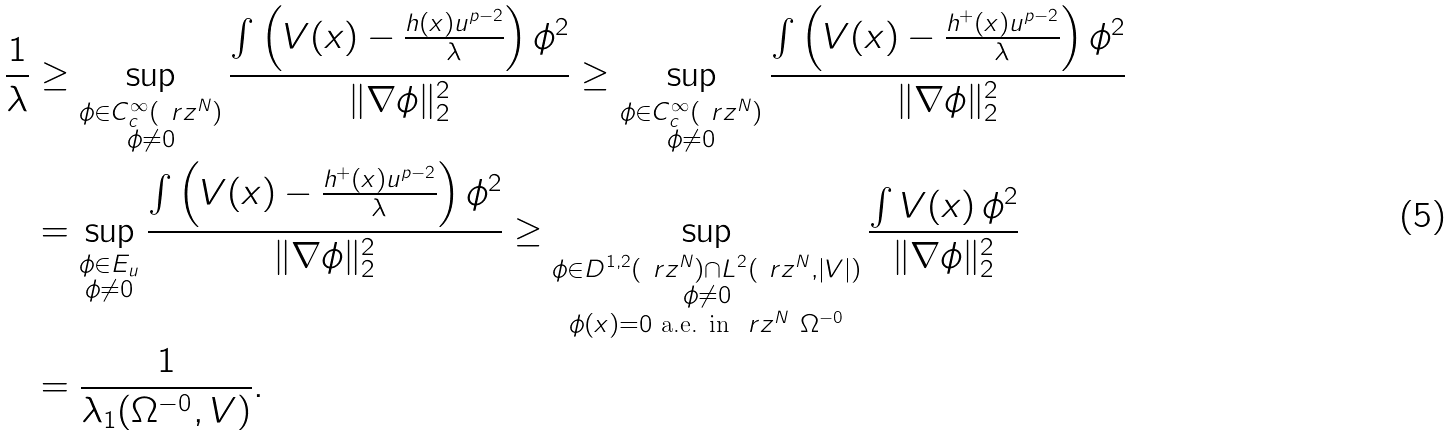Convert formula to latex. <formula><loc_0><loc_0><loc_500><loc_500>\frac { 1 } { \lambda } & \geq \sup _ { \substack { \phi \in C _ { c } ^ { \infty } ( \ r z ^ { N } ) \\ \phi \neq 0 } } \frac { \int \left ( V ( x ) - \frac { h ( x ) u ^ { p - 2 } } { \lambda } \right ) \phi ^ { 2 } } { \| \nabla \phi \| _ { 2 } ^ { 2 } } \geq \sup _ { \substack { \phi \in C _ { c } ^ { \infty } ( \ r z ^ { N } ) \\ \phi \neq 0 } } \frac { \int \left ( V ( x ) - \frac { h ^ { + } ( x ) u ^ { p - 2 } } { \lambda } \right ) \phi ^ { 2 } } { \| \nabla \phi \| _ { 2 } ^ { 2 } } \\ & = \sup _ { \substack { \phi \in E _ { u } \\ \phi \neq 0 } } \frac { \int \left ( V ( x ) - \frac { h ^ { + } ( x ) u ^ { p - 2 } } { \lambda } \right ) \phi ^ { 2 } } { \| \nabla \phi \| _ { 2 } ^ { 2 } } \geq \sup _ { \substack { \phi \in D ^ { 1 , 2 } ( \ r z ^ { N } ) \cap L ^ { 2 } ( \ r z ^ { N } , | V | ) \\ \phi \neq 0 \\ \phi ( x ) = 0 \text { a.e. in } \ r z ^ { N } \ \Omega ^ { - 0 } } } \frac { \int V ( x ) \, \phi ^ { 2 } } { \| \nabla \phi \| _ { 2 } ^ { 2 } } \\ & = \frac { 1 } { \lambda _ { 1 } ( \Omega ^ { - 0 } , V ) } .</formula> 